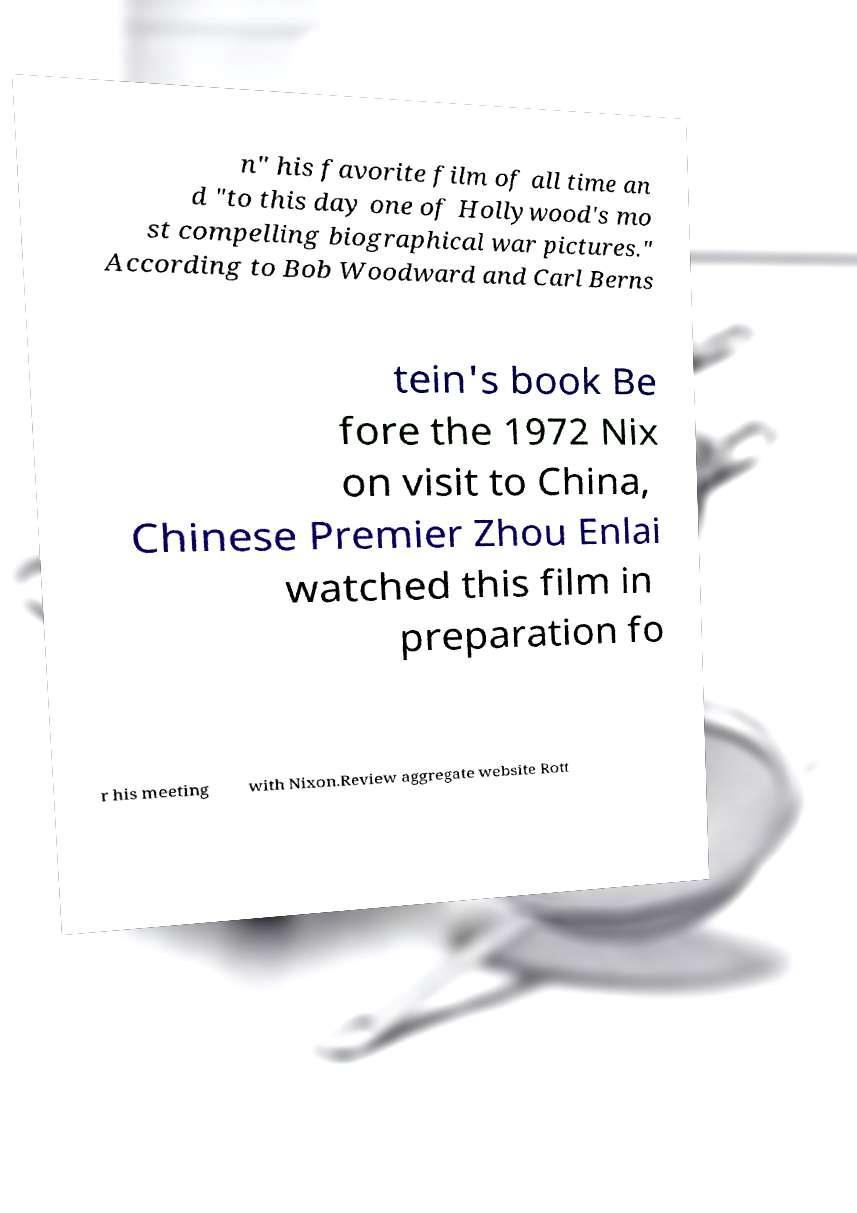Could you extract and type out the text from this image? n" his favorite film of all time an d "to this day one of Hollywood's mo st compelling biographical war pictures." According to Bob Woodward and Carl Berns tein's book Be fore the 1972 Nix on visit to China, Chinese Premier Zhou Enlai watched this film in preparation fo r his meeting with Nixon.Review aggregate website Rott 